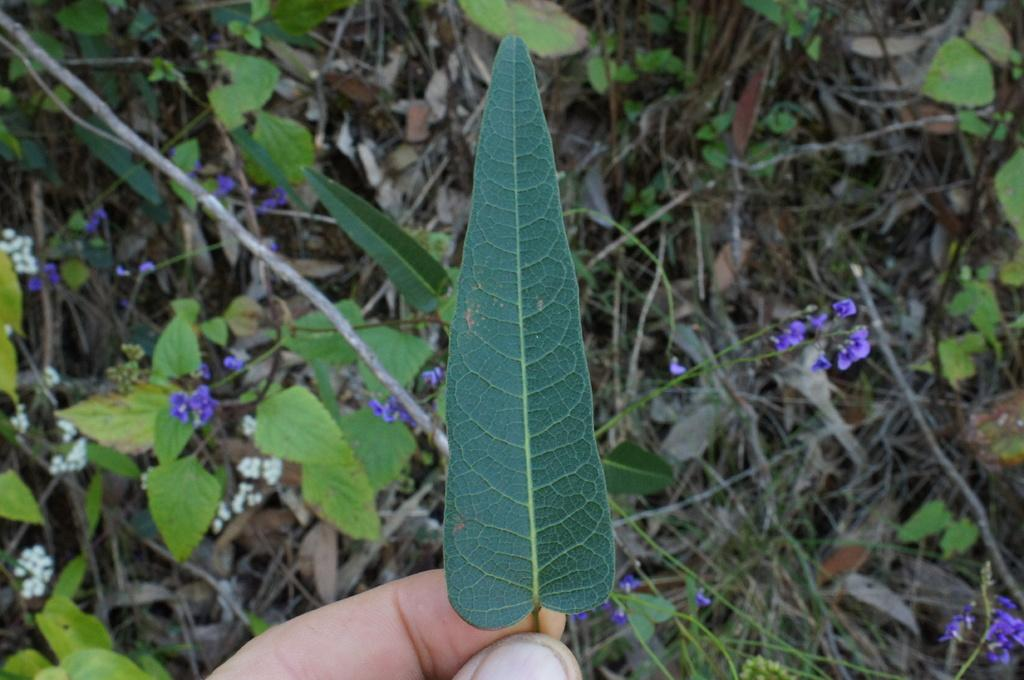What is the person's hand holding in the image? The person's hand is holding a leaf in the image. What can be seen in the background of the image? There are many leaves and branches behind the leaf in the image. What type of flowers are present in the image? There are white flowers and violet flowers in the image. What type of grape is being traded in the image? There is no grape or any indication of trade present in the image. 